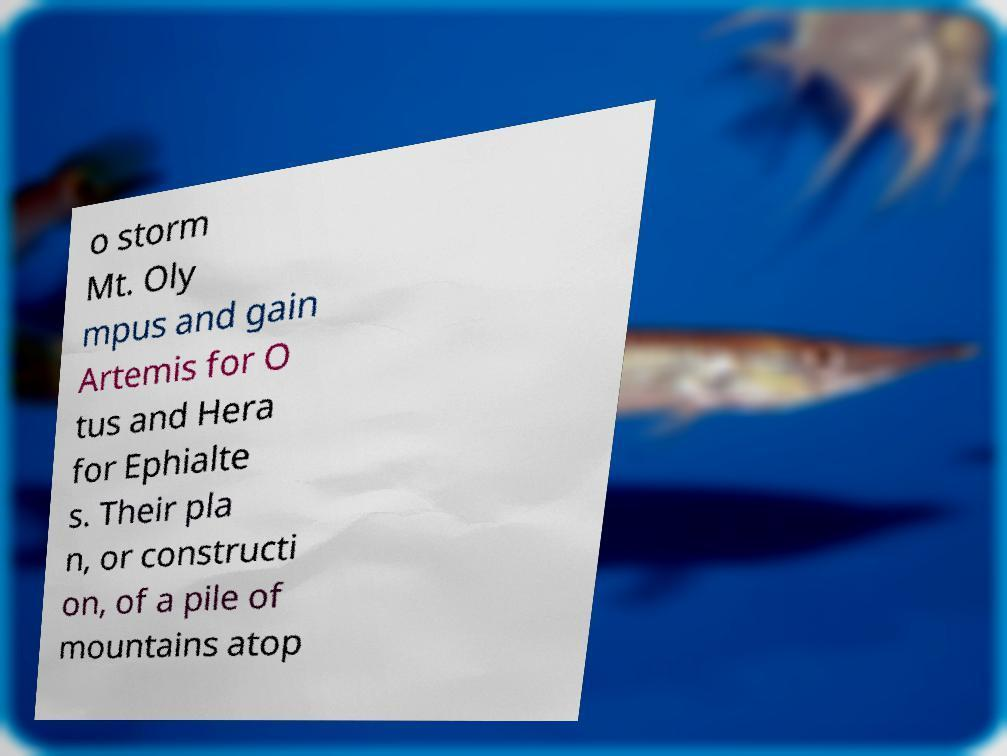Could you assist in decoding the text presented in this image and type it out clearly? o storm Mt. Oly mpus and gain Artemis for O tus and Hera for Ephialte s. Their pla n, or constructi on, of a pile of mountains atop 